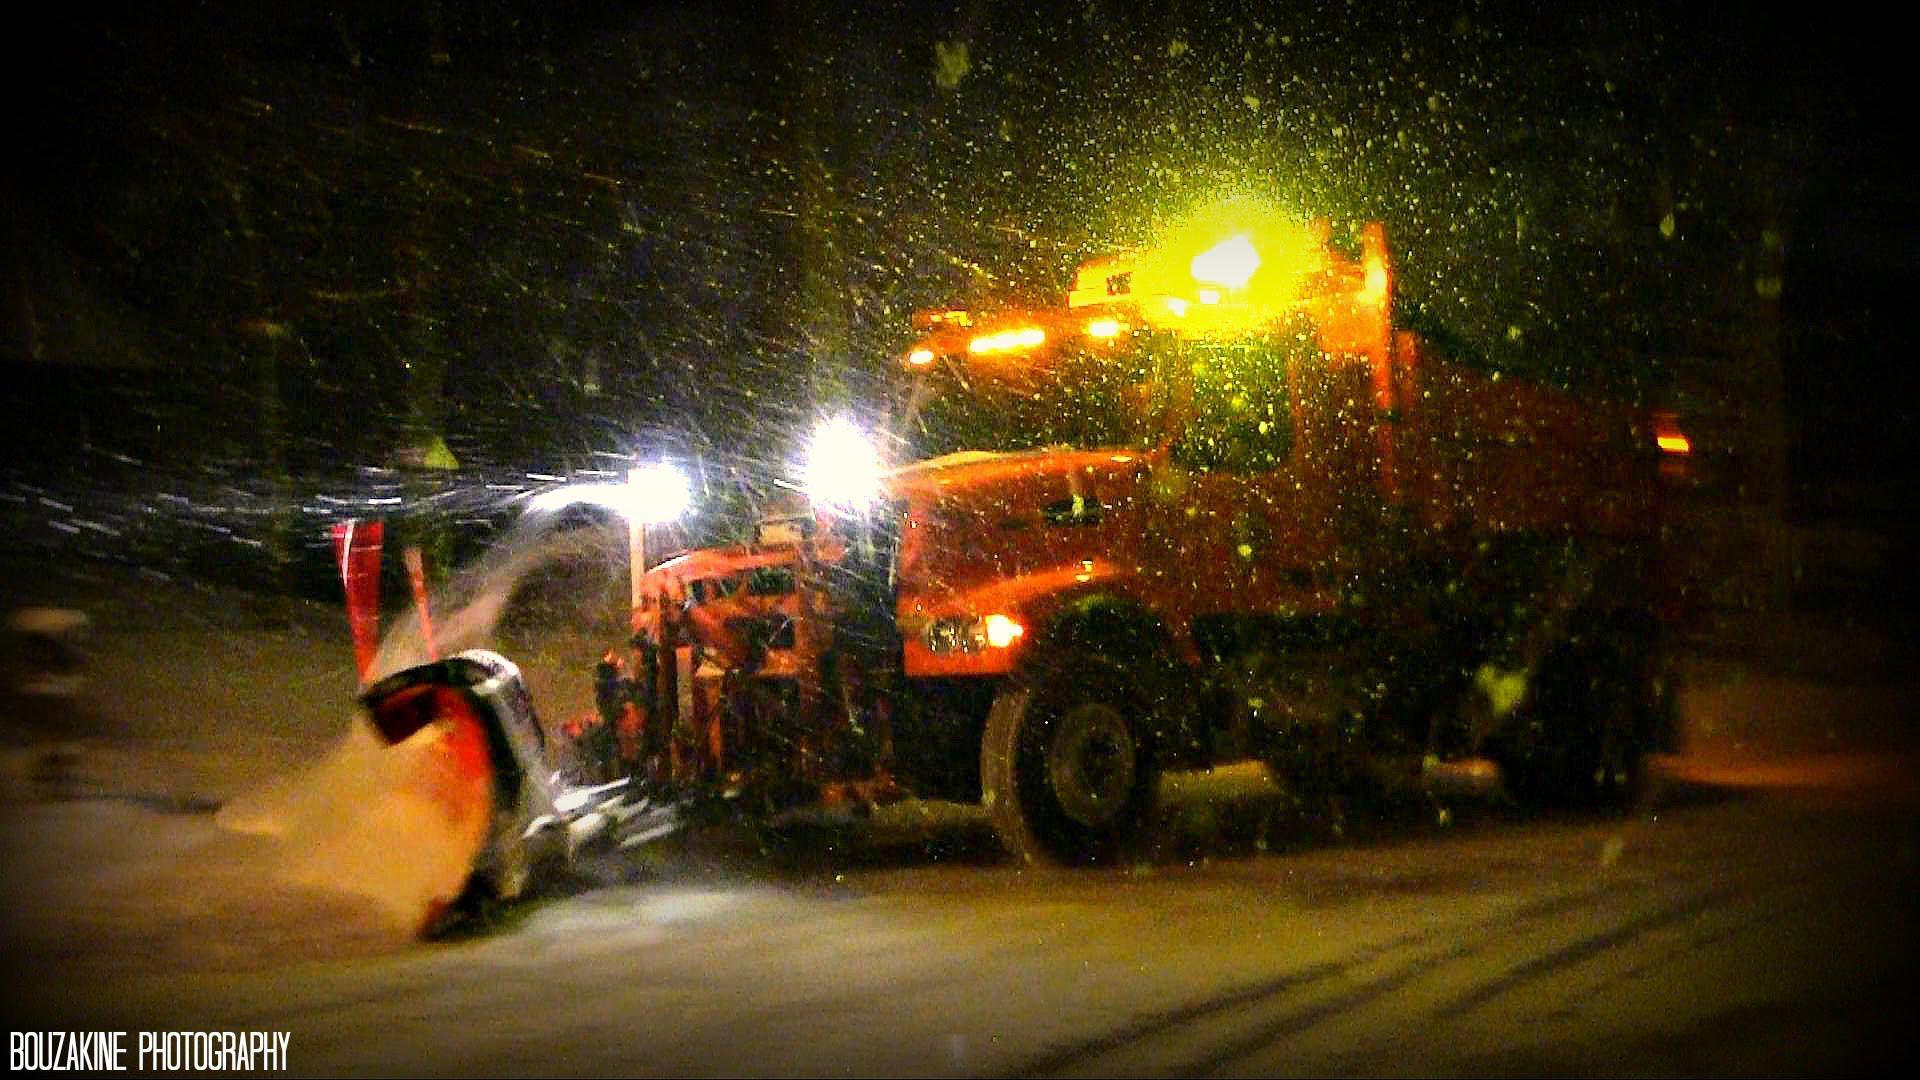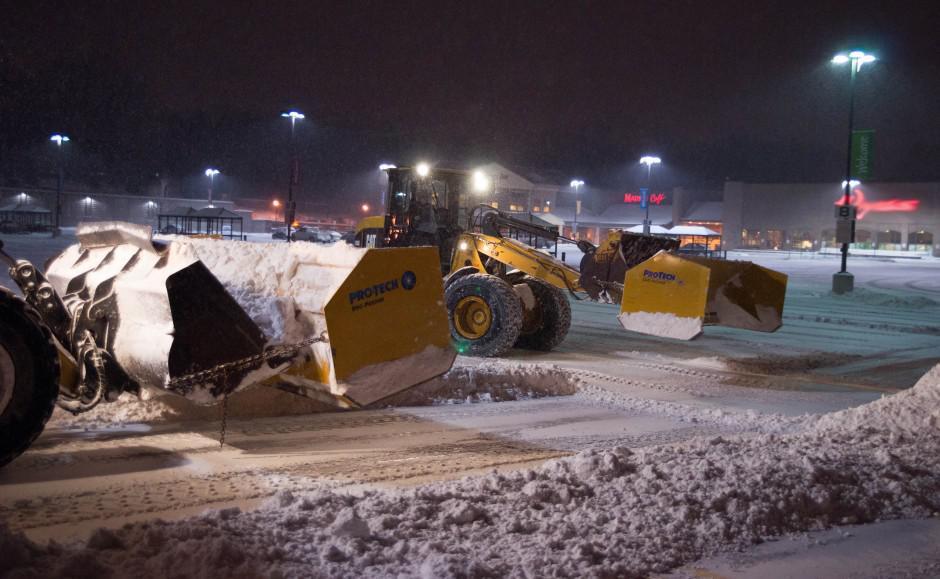The first image is the image on the left, the second image is the image on the right. For the images shown, is this caption "An image shows a tractor-type plow with two bright white lights at the top pushing snow as the snow falls around it." true? Answer yes or no. No. The first image is the image on the left, the second image is the image on the right. Evaluate the accuracy of this statement regarding the images: "There is a total of two trackers plowing snow.". Is it true? Answer yes or no. No. 